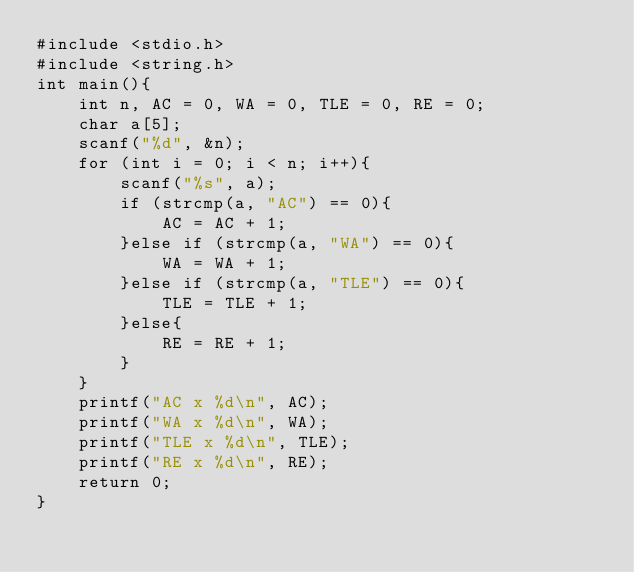Convert code to text. <code><loc_0><loc_0><loc_500><loc_500><_C_>#include <stdio.h>
#include <string.h>
int main(){
    int n, AC = 0, WA = 0, TLE = 0, RE = 0;
    char a[5];
    scanf("%d", &n);
    for (int i = 0; i < n; i++){
        scanf("%s", a);
        if (strcmp(a, "AC") == 0){
            AC = AC + 1;
        }else if (strcmp(a, "WA") == 0){
            WA = WA + 1;
        }else if (strcmp(a, "TLE") == 0){
            TLE = TLE + 1;
        }else{
            RE = RE + 1;
        }
    }
    printf("AC x %d\n", AC);
    printf("WA x %d\n", WA);
    printf("TLE x %d\n", TLE);
    printf("RE x %d\n", RE);
    return 0;
}</code> 